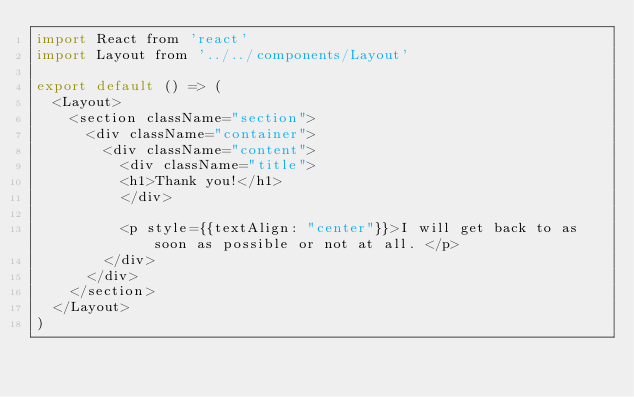<code> <loc_0><loc_0><loc_500><loc_500><_JavaScript_>import React from 'react'
import Layout from '../../components/Layout'

export default () => (
  <Layout>
    <section className="section">
      <div className="container">
        <div className="content">
          <div className="title">
          <h1>Thank you!</h1>
          </div>
         
          <p style={{textAlign: "center"}}>I will get back to as soon as possible or not at all. </p>
        </div>
      </div>
    </section>
  </Layout>
)
</code> 